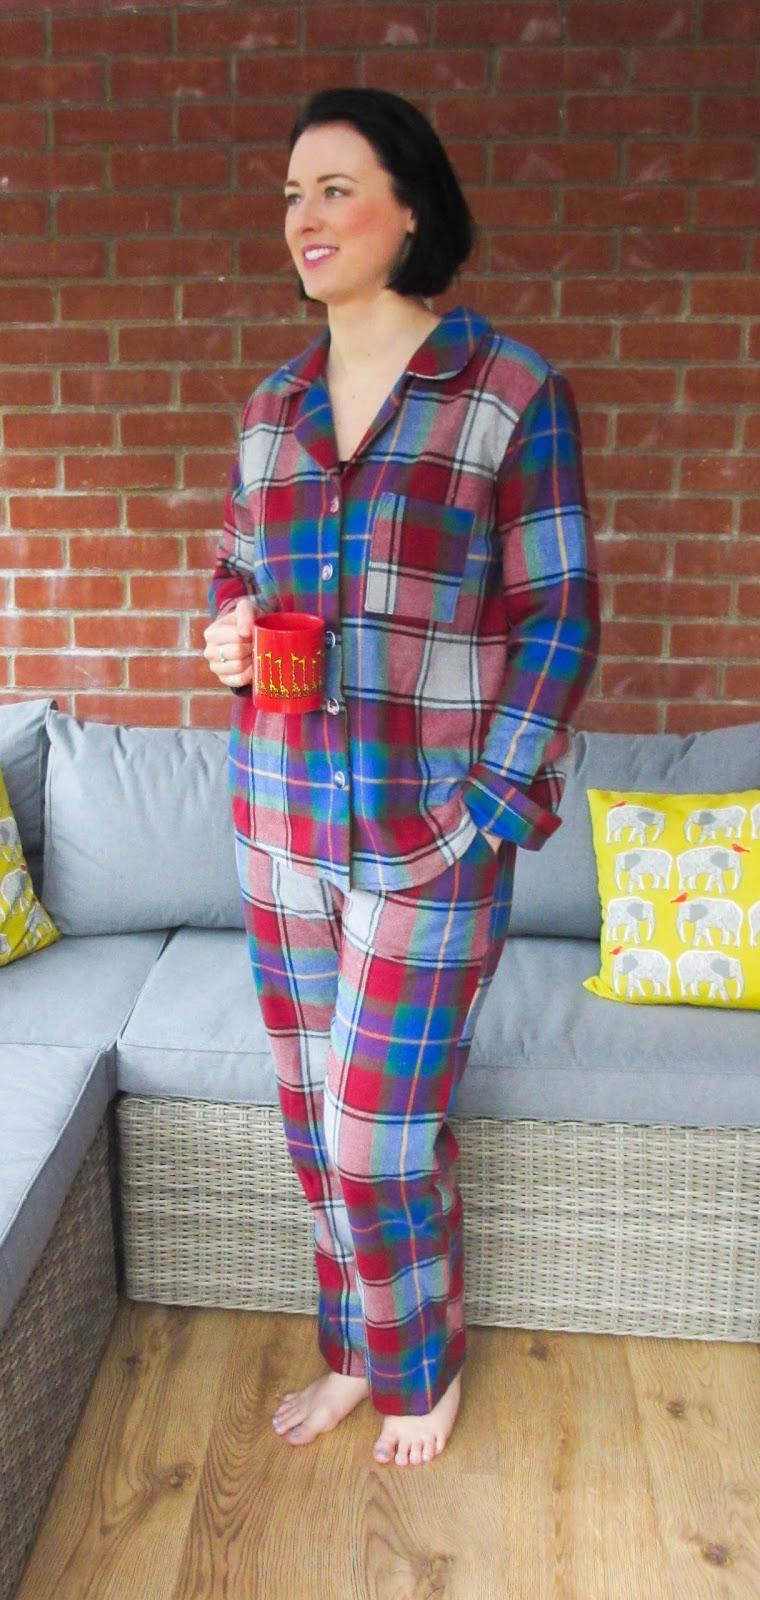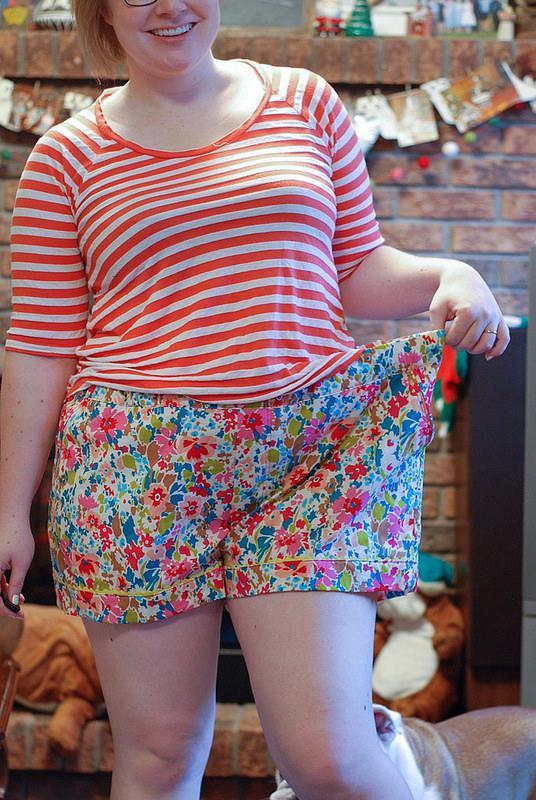The first image is the image on the left, the second image is the image on the right. Considering the images on both sides, is "One image has two ladies with one of the ladies wearing shorts." valid? Answer yes or no. No. 